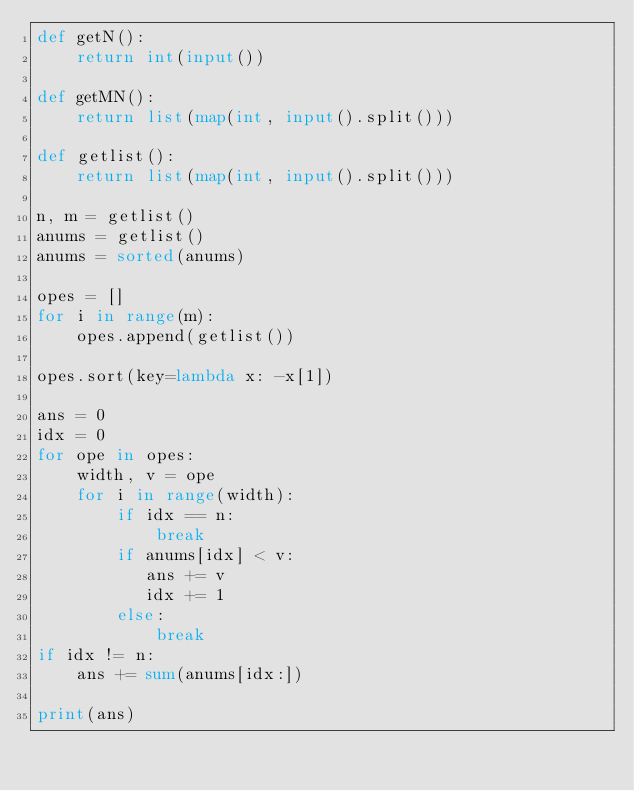Convert code to text. <code><loc_0><loc_0><loc_500><loc_500><_Python_>def getN():
    return int(input())

def getMN():
    return list(map(int, input().split()))

def getlist():
    return list(map(int, input().split()))

n, m = getlist()
anums = getlist()
anums = sorted(anums)

opes = []
for i in range(m):
    opes.append(getlist())

opes.sort(key=lambda x: -x[1])

ans = 0
idx = 0
for ope in opes:
    width, v = ope
    for i in range(width):
        if idx == n:
            break
        if anums[idx] < v:
           ans += v
           idx += 1
        else:
            break
if idx != n:
    ans += sum(anums[idx:])

print(ans)</code> 